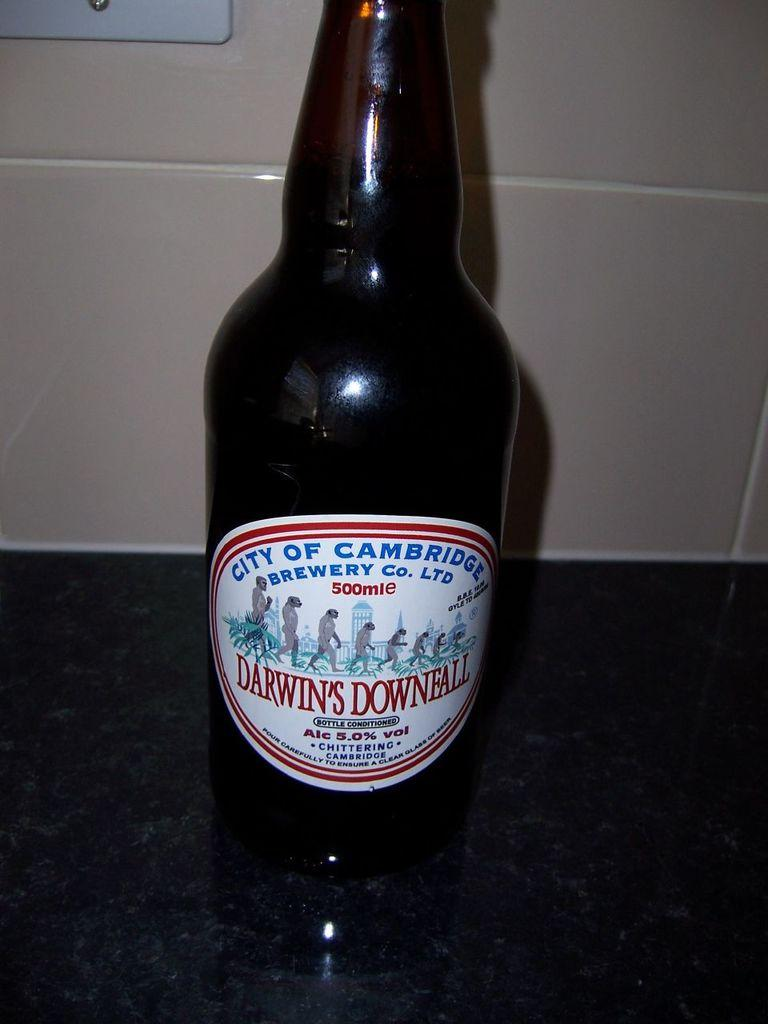Provide a one-sentence caption for the provided image. Bottle of Darwin's Downfall brewery beer that contains alcohol. 